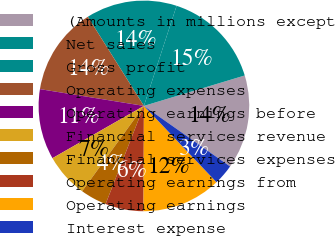Convert chart to OTSL. <chart><loc_0><loc_0><loc_500><loc_500><pie_chart><fcel>(Amounts in millions except<fcel>Net sales<fcel>Gross profit<fcel>Operating expenses<fcel>Operating earnings before<fcel>Financial services revenue<fcel>Financial services expenses<fcel>Operating earnings from<fcel>Operating earnings<fcel>Interest expense<nl><fcel>14.41%<fcel>15.31%<fcel>13.96%<fcel>13.51%<fcel>10.81%<fcel>6.76%<fcel>4.05%<fcel>5.86%<fcel>12.16%<fcel>3.15%<nl></chart> 